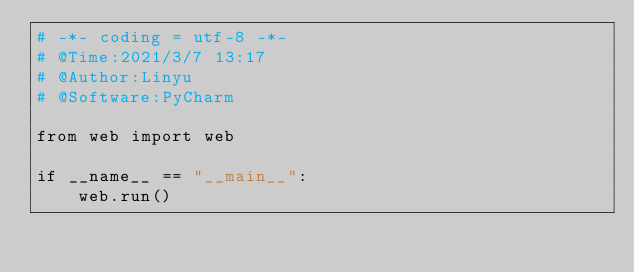<code> <loc_0><loc_0><loc_500><loc_500><_Python_># -*- coding = utf-8 -*-
# @Time:2021/3/7 13:17
# @Author:Linyu
# @Software:PyCharm

from web import web

if __name__ == "__main__":
    web.run()</code> 